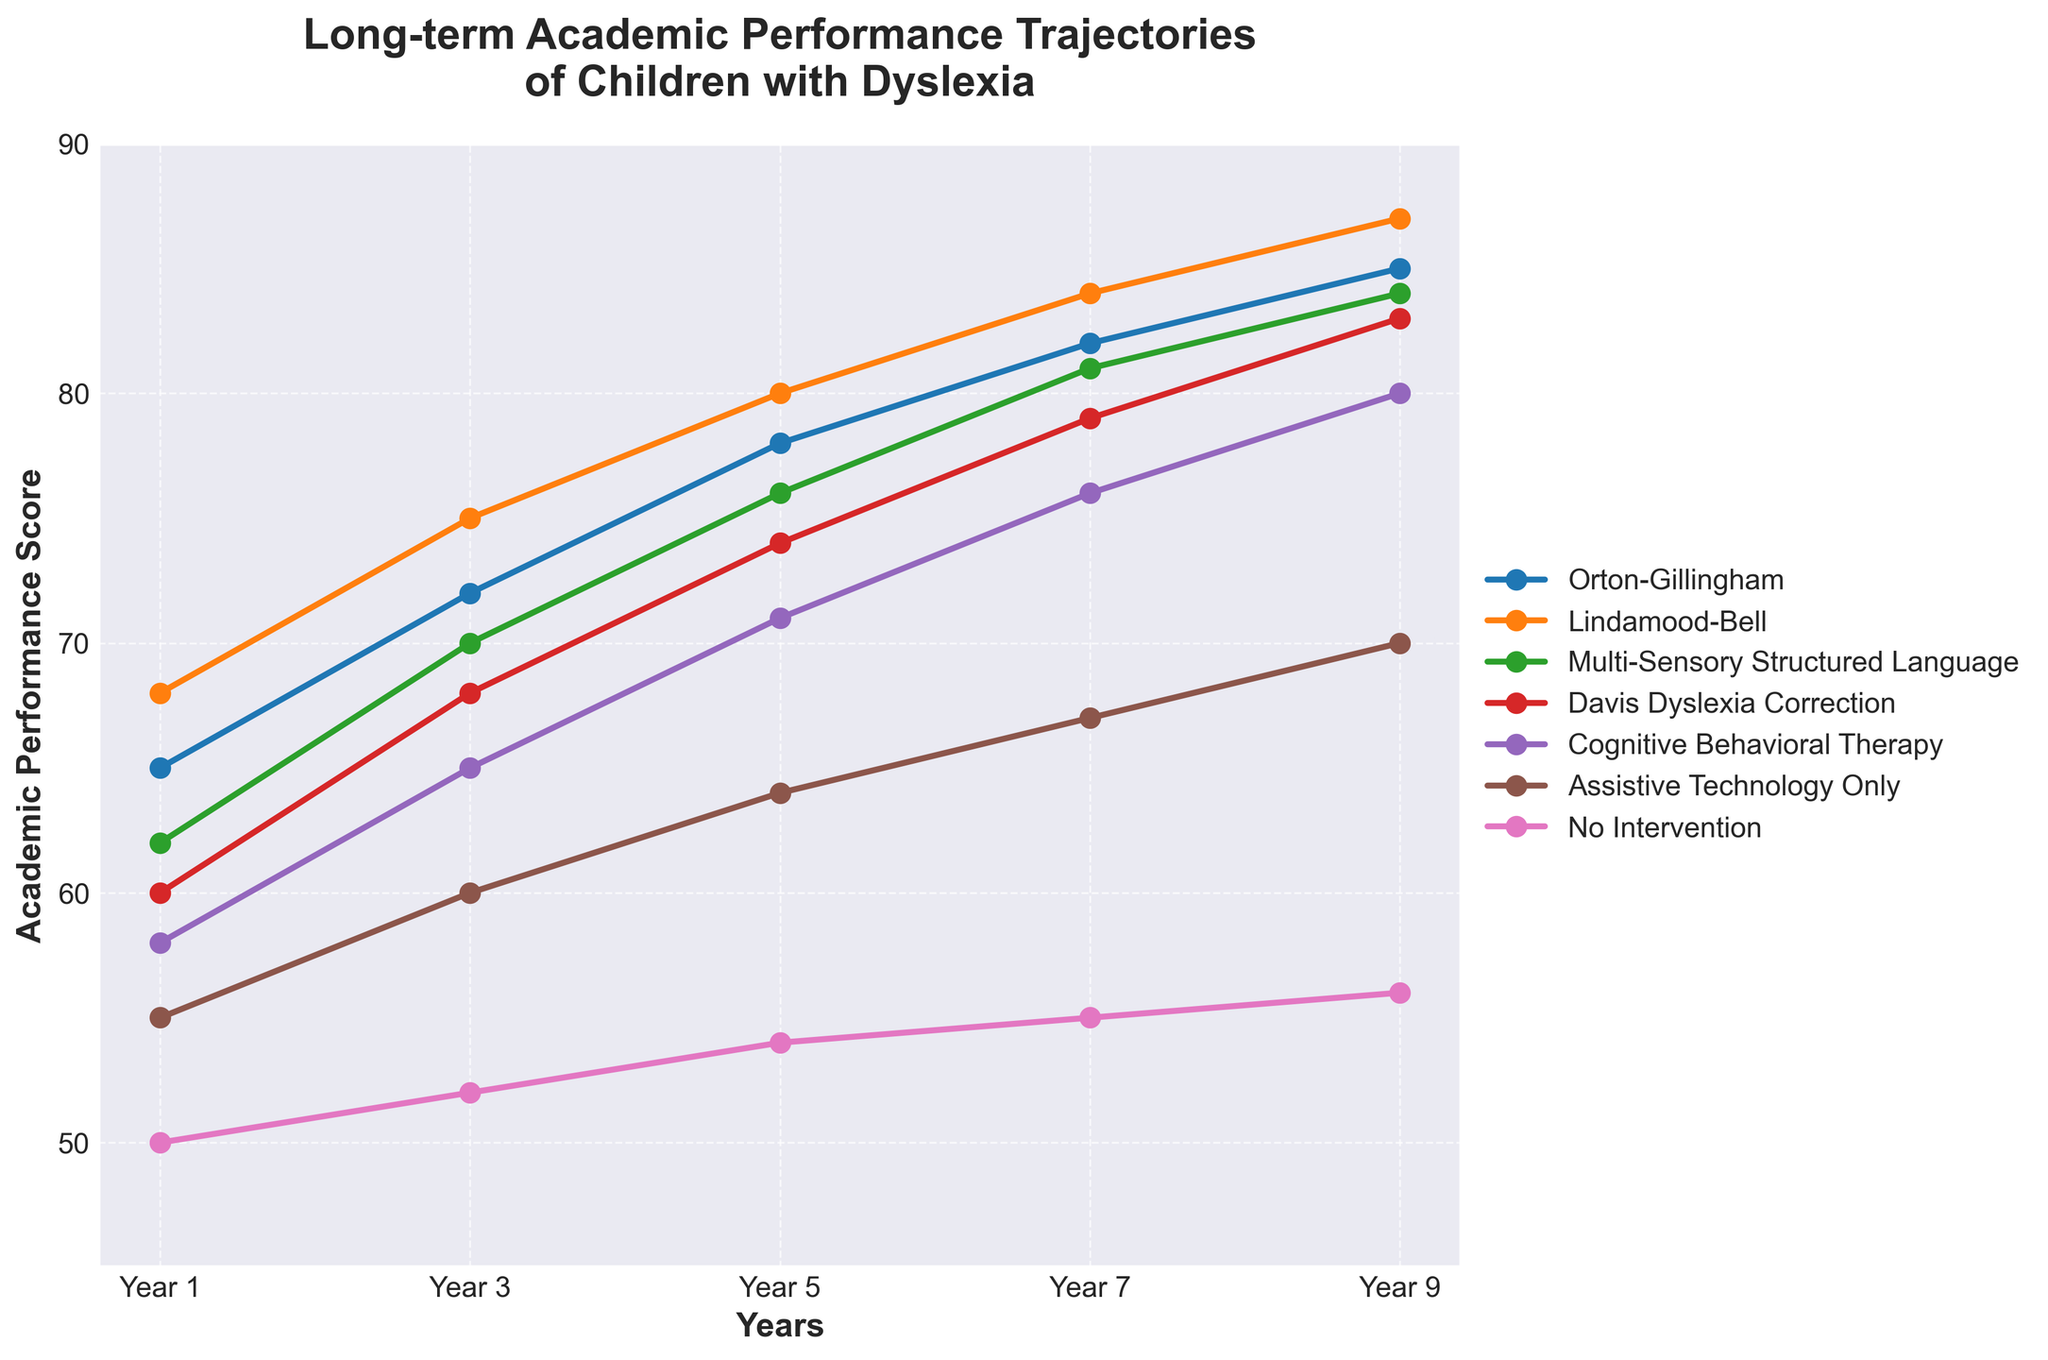What type of intervention shows the highest academic performance in Year 9? Identify the trend lines on the plot and locate the one that ends at the highest point on the y-axis for Year 9. The "Lindamood-Bell" line is the highest, reaching an academic performance score of 87.
Answer: Lindamood-Bell Which intervention shows a larger improvement from Year 1 to Year 3, Orton-Gillingham or Davis Dyslexia Correction? Check the increase in academic performance scores from Year 1 to Year 3 for both interventions. Orton-Gillingham increases from 65 to 72, which is a 7 point increase, while Davis Dyslexia Correction increases from 60 to 68, which is an 8 point increase.
Answer: Davis Dyslexia Correction What is the average academic performance score across all interventions in Year 5? Sum the academic performance scores for all interventions in Year 5 and divide by the number of interventions. (78 + 80 + 76 + 74 + 71 + 64 + 54) / 7 = 497 / 7 = 71
Answer: 71 Which intervention has the smallest improvement in academic performance from Year 1 to Year 9? Find the difference between Year 1 and Year 9 scores for each intervention. The differences are: Orton-Gillingham 20, Lindamood-Bell 19, Multi-Sensory Structured Language 22, Davis Dyslexia Correction 23, Cognitive Behavioral Therapy 22, Assistive Technology Only 15, No Intervention 6. The smallest improvement is for "No Intervention" with 6 points.
Answer: No Intervention Which year shows the biggest gap in academic performance between Orton-Gillingham and No Intervention? Calculate the performance gap between Orton-Gillingham and No Intervention for each year and identify the largest one. Year 1: 65 - 50 = 15, Year 3: 72 - 52 = 20, Year 5: 78 - 54 = 24, Year 7: 82 - 55 = 27, Year 9: 85 - 56 = 29. The biggest gap is in Year 9 with 29 points.
Answer: Year 9 How does the academic performance trend for Assistive Technology Only compare with Cognitive Behavioral Therapy? Compare the slopes of the trend lines for both interventions across the years. Assistive Technology Only shows a flatter, slower improvement trajectory starting at 55 and ending at 70 (15 points improvement), whereas Cognitive Behavioral Therapy shows a steeper improvement starting at 58 and ending at 80 (22 points).
Answer: Cognitive Behavioral Therapy shows more improvement What is the total improvement in academic performance for Multi-Sensory Structured Language from Year 1 to Year 7? Subtract the Year 1 score from the Year 7 score for Multi-Sensory Structured Language. 81 - 62 = 19
Answer: 19 Which intervention type shows the second-highest performance in Year 7? Identify the intervention with the second-highest point on the y-axis for Year 7. Lindamood-Bell is the highest with 84, and Orton-Gillingham is second with 82.
Answer: Orton-Gillingham 